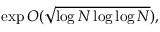<formula> <loc_0><loc_0><loc_500><loc_500>\exp O ( { \sqrt { \log N \log \log N } } ) ,</formula> 